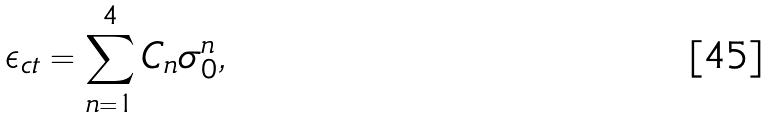Convert formula to latex. <formula><loc_0><loc_0><loc_500><loc_500>\epsilon _ { c t } = \sum _ { n = 1 } ^ { 4 } C _ { n } \sigma _ { 0 } ^ { n } ,</formula> 